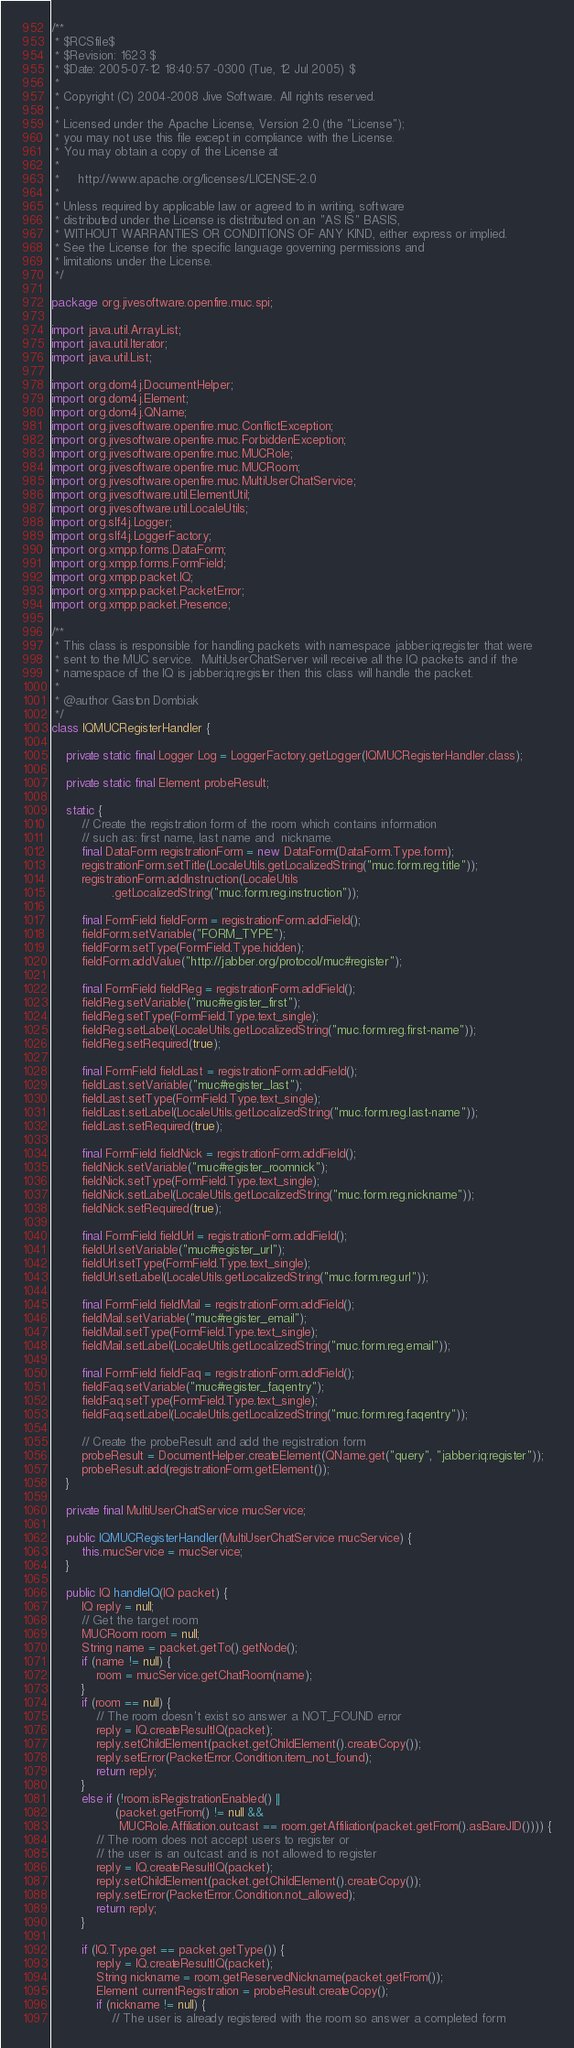Convert code to text. <code><loc_0><loc_0><loc_500><loc_500><_Java_>/**
 * $RCSfile$
 * $Revision: 1623 $
 * $Date: 2005-07-12 18:40:57 -0300 (Tue, 12 Jul 2005) $
 *
 * Copyright (C) 2004-2008 Jive Software. All rights reserved.
 *
 * Licensed under the Apache License, Version 2.0 (the "License");
 * you may not use this file except in compliance with the License.
 * You may obtain a copy of the License at
 *
 *     http://www.apache.org/licenses/LICENSE-2.0
 *
 * Unless required by applicable law or agreed to in writing, software
 * distributed under the License is distributed on an "AS IS" BASIS,
 * WITHOUT WARRANTIES OR CONDITIONS OF ANY KIND, either express or implied.
 * See the License for the specific language governing permissions and
 * limitations under the License.
 */

package org.jivesoftware.openfire.muc.spi;

import java.util.ArrayList;
import java.util.Iterator;
import java.util.List;

import org.dom4j.DocumentHelper;
import org.dom4j.Element;
import org.dom4j.QName;
import org.jivesoftware.openfire.muc.ConflictException;
import org.jivesoftware.openfire.muc.ForbiddenException;
import org.jivesoftware.openfire.muc.MUCRole;
import org.jivesoftware.openfire.muc.MUCRoom;
import org.jivesoftware.openfire.muc.MultiUserChatService;
import org.jivesoftware.util.ElementUtil;
import org.jivesoftware.util.LocaleUtils;
import org.slf4j.Logger;
import org.slf4j.LoggerFactory;
import org.xmpp.forms.DataForm;
import org.xmpp.forms.FormField;
import org.xmpp.packet.IQ;
import org.xmpp.packet.PacketError;
import org.xmpp.packet.Presence;

/**
 * This class is responsible for handling packets with namespace jabber:iq:register that were
 * sent to the MUC service.  MultiUserChatServer will receive all the IQ packets and if the
 * namespace of the IQ is jabber:iq:register then this class will handle the packet.
 * 
 * @author Gaston Dombiak
 */
class IQMUCRegisterHandler {

	private static final Logger Log = LoggerFactory.getLogger(IQMUCRegisterHandler.class);

    private static final Element probeResult;
    
    static {
        // Create the registration form of the room which contains information
        // such as: first name, last name and  nickname.
        final DataForm registrationForm = new DataForm(DataForm.Type.form);
        registrationForm.setTitle(LocaleUtils.getLocalizedString("muc.form.reg.title"));
        registrationForm.addInstruction(LocaleUtils
                .getLocalizedString("muc.form.reg.instruction"));

        final FormField fieldForm = registrationForm.addField();
        fieldForm.setVariable("FORM_TYPE");
        fieldForm.setType(FormField.Type.hidden);
        fieldForm.addValue("http://jabber.org/protocol/muc#register");

        final FormField fieldReg = registrationForm.addField();
        fieldReg.setVariable("muc#register_first");
        fieldReg.setType(FormField.Type.text_single);
        fieldReg.setLabel(LocaleUtils.getLocalizedString("muc.form.reg.first-name"));
        fieldReg.setRequired(true);

        final FormField fieldLast = registrationForm.addField();
        fieldLast.setVariable("muc#register_last");
        fieldLast.setType(FormField.Type.text_single);
        fieldLast.setLabel(LocaleUtils.getLocalizedString("muc.form.reg.last-name"));
        fieldLast.setRequired(true);

        final FormField fieldNick = registrationForm.addField();
        fieldNick.setVariable("muc#register_roomnick");
        fieldNick.setType(FormField.Type.text_single);
        fieldNick.setLabel(LocaleUtils.getLocalizedString("muc.form.reg.nickname"));
        fieldNick.setRequired(true);

        final FormField fieldUrl = registrationForm.addField();
        fieldUrl.setVariable("muc#register_url");
        fieldUrl.setType(FormField.Type.text_single);
        fieldUrl.setLabel(LocaleUtils.getLocalizedString("muc.form.reg.url"));

        final FormField fieldMail = registrationForm.addField();
        fieldMail.setVariable("muc#register_email");
        fieldMail.setType(FormField.Type.text_single);
        fieldMail.setLabel(LocaleUtils.getLocalizedString("muc.form.reg.email"));

        final FormField fieldFaq = registrationForm.addField();
        fieldFaq.setVariable("muc#register_faqentry");
        fieldFaq.setType(FormField.Type.text_single);
        fieldFaq.setLabel(LocaleUtils.getLocalizedString("muc.form.reg.faqentry"));

        // Create the probeResult and add the registration form
        probeResult = DocumentHelper.createElement(QName.get("query", "jabber:iq:register"));
        probeResult.add(registrationForm.getElement());
    }
    
    private final MultiUserChatService mucService;

    public IQMUCRegisterHandler(MultiUserChatService mucService) {
        this.mucService = mucService;
    }

    public IQ handleIQ(IQ packet) {
        IQ reply = null;
        // Get the target room
        MUCRoom room = null;
        String name = packet.getTo().getNode();
        if (name != null) {
            room = mucService.getChatRoom(name);
        }
        if (room == null) {
            // The room doesn't exist so answer a NOT_FOUND error
            reply = IQ.createResultIQ(packet);
            reply.setChildElement(packet.getChildElement().createCopy());
            reply.setError(PacketError.Condition.item_not_found);
            return reply;
        }
        else if (!room.isRegistrationEnabled() ||
                 (packet.getFrom() != null && 
                  MUCRole.Affiliation.outcast == room.getAffiliation(packet.getFrom().asBareJID()))) {
            // The room does not accept users to register or
            // the user is an outcast and is not allowed to register
            reply = IQ.createResultIQ(packet);
            reply.setChildElement(packet.getChildElement().createCopy());
            reply.setError(PacketError.Condition.not_allowed);
            return reply;
        }

        if (IQ.Type.get == packet.getType()) {
            reply = IQ.createResultIQ(packet);
            String nickname = room.getReservedNickname(packet.getFrom());
            Element currentRegistration = probeResult.createCopy();
            if (nickname != null) {
                // The user is already registered with the room so answer a completed form</code> 